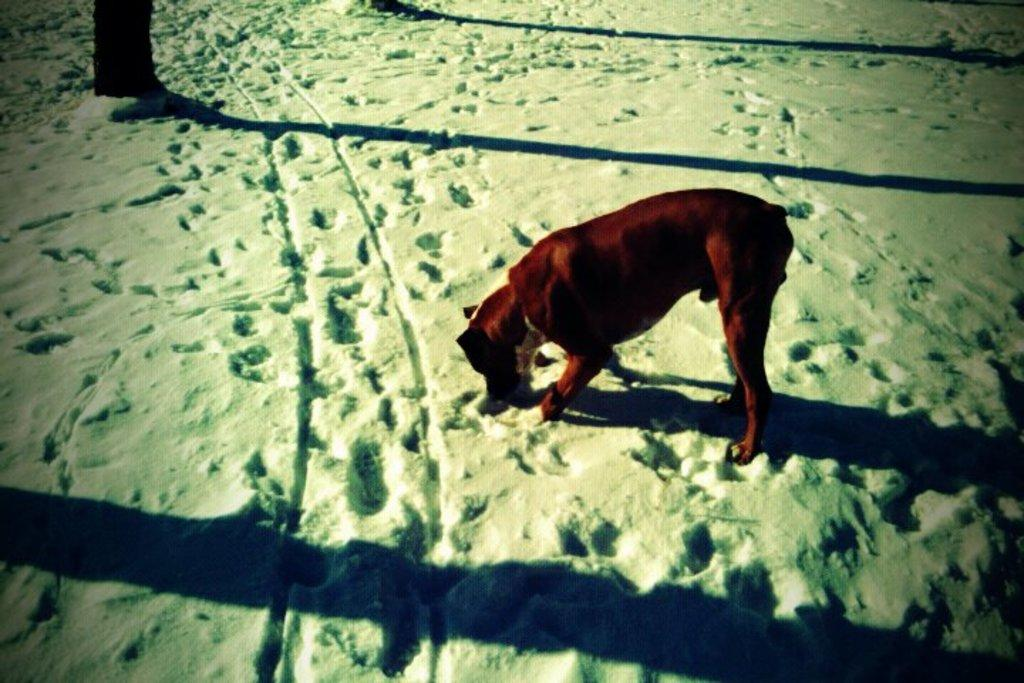What is the main subject in the center of the image? There is an animal in the center of the image. What type of terrain is the animal on? The animal is on the snow. Can you describe any other visual elements in the image? There are shadows visible in the image. What color of crayon is being used to draw the animal in the image? There is no crayon present in the image; it is a photograph or illustration of the animal. How is the glue being used in the image? There is no glue present in the image. 